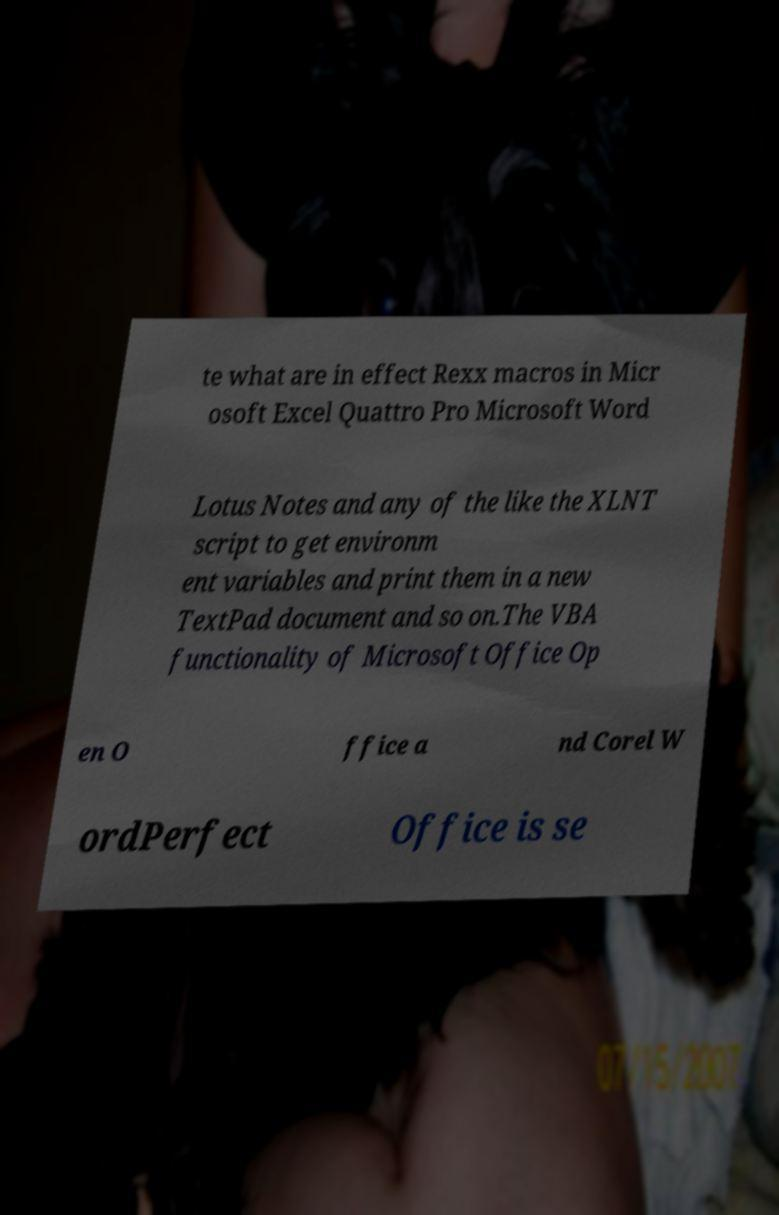Can you accurately transcribe the text from the provided image for me? te what are in effect Rexx macros in Micr osoft Excel Quattro Pro Microsoft Word Lotus Notes and any of the like the XLNT script to get environm ent variables and print them in a new TextPad document and so on.The VBA functionality of Microsoft Office Op en O ffice a nd Corel W ordPerfect Office is se 